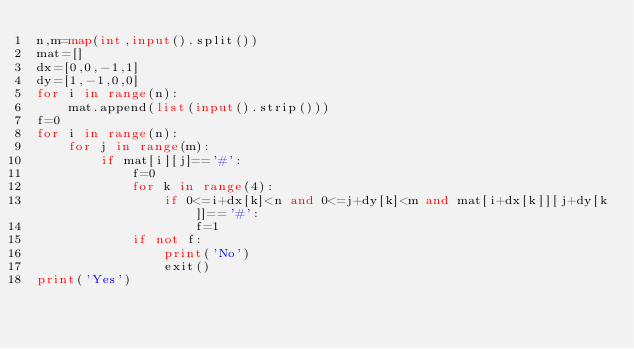<code> <loc_0><loc_0><loc_500><loc_500><_Python_>n,m=map(int,input().split())
mat=[]
dx=[0,0,-1,1]
dy=[1,-1,0,0]
for i in range(n):
    mat.append(list(input().strip()))
f=0 
for i in range(n):
    for j in range(m):
        if mat[i][j]=='#':
            f=0 
            for k in range(4): 
                if 0<=i+dx[k]<n and 0<=j+dy[k]<m and mat[i+dx[k]][j+dy[k]]=='#': 
                    f=1  
            if not f:
                print('No')
                exit()
print('Yes')
</code> 